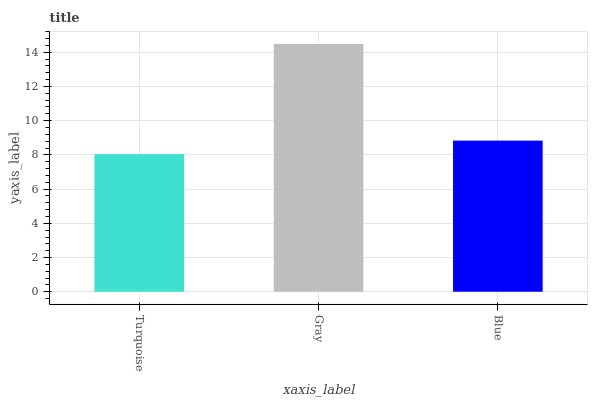Is Turquoise the minimum?
Answer yes or no. Yes. Is Gray the maximum?
Answer yes or no. Yes. Is Blue the minimum?
Answer yes or no. No. Is Blue the maximum?
Answer yes or no. No. Is Gray greater than Blue?
Answer yes or no. Yes. Is Blue less than Gray?
Answer yes or no. Yes. Is Blue greater than Gray?
Answer yes or no. No. Is Gray less than Blue?
Answer yes or no. No. Is Blue the high median?
Answer yes or no. Yes. Is Blue the low median?
Answer yes or no. Yes. Is Gray the high median?
Answer yes or no. No. Is Gray the low median?
Answer yes or no. No. 